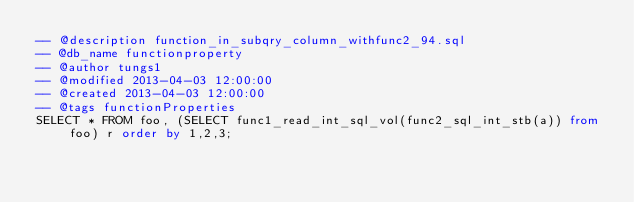Convert code to text. <code><loc_0><loc_0><loc_500><loc_500><_SQL_>-- @description function_in_subqry_column_withfunc2_94.sql
-- @db_name functionproperty
-- @author tungs1
-- @modified 2013-04-03 12:00:00
-- @created 2013-04-03 12:00:00
-- @tags functionProperties 
SELECT * FROM foo, (SELECT func1_read_int_sql_vol(func2_sql_int_stb(a)) from foo) r order by 1,2,3; 
</code> 